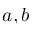Convert formula to latex. <formula><loc_0><loc_0><loc_500><loc_500>a , b</formula> 